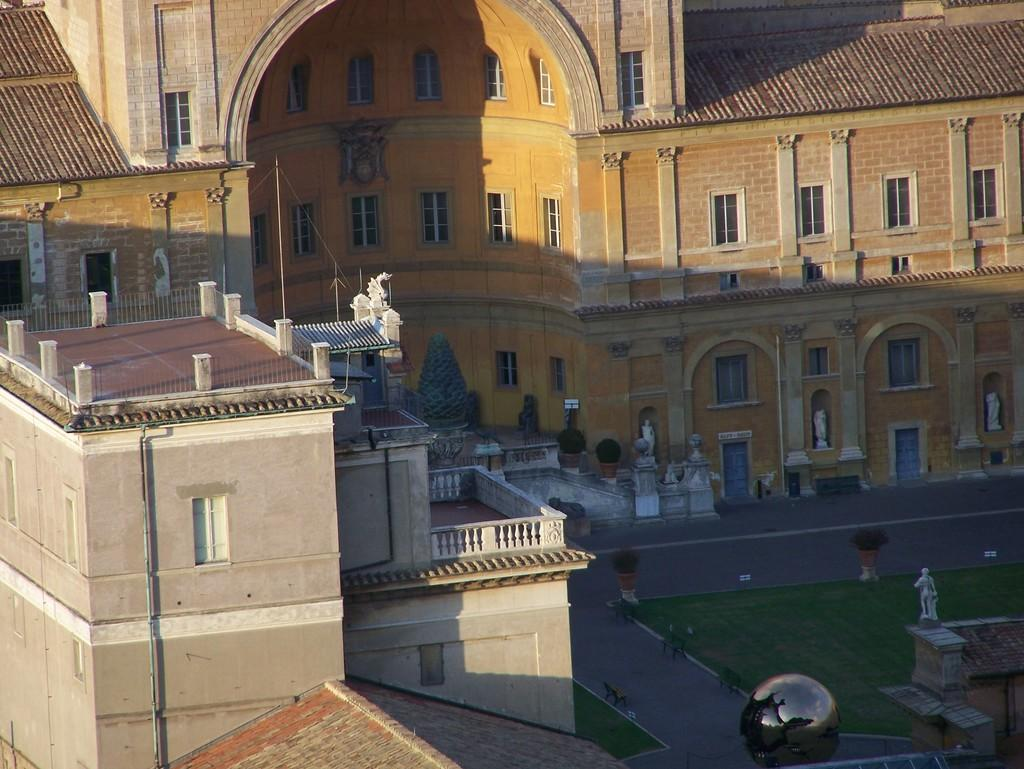What type of structures can be seen in the image? There are buildings in the image. What architectural features are present on the buildings? There are windows and railings visible on the buildings. What type of surface is present in the image? There is a road and grass on the ground in the image. What type of vegetation is present in the image? There are plants in the image. What type of decorative elements can be seen in the image? There are statues on platforms in the image. What is the shape of the object at the bottom of the image? There is a spherical object at the bottom of the image. How much debt is represented by the hair on the statue in the image? There is no hair present on the statues in the image, and therefore no debt can be associated with it. How many fingers can be seen on the spherical object at the bottom of the image? The spherical object at the bottom of the image does not have fingers, as it is a non-living object. 